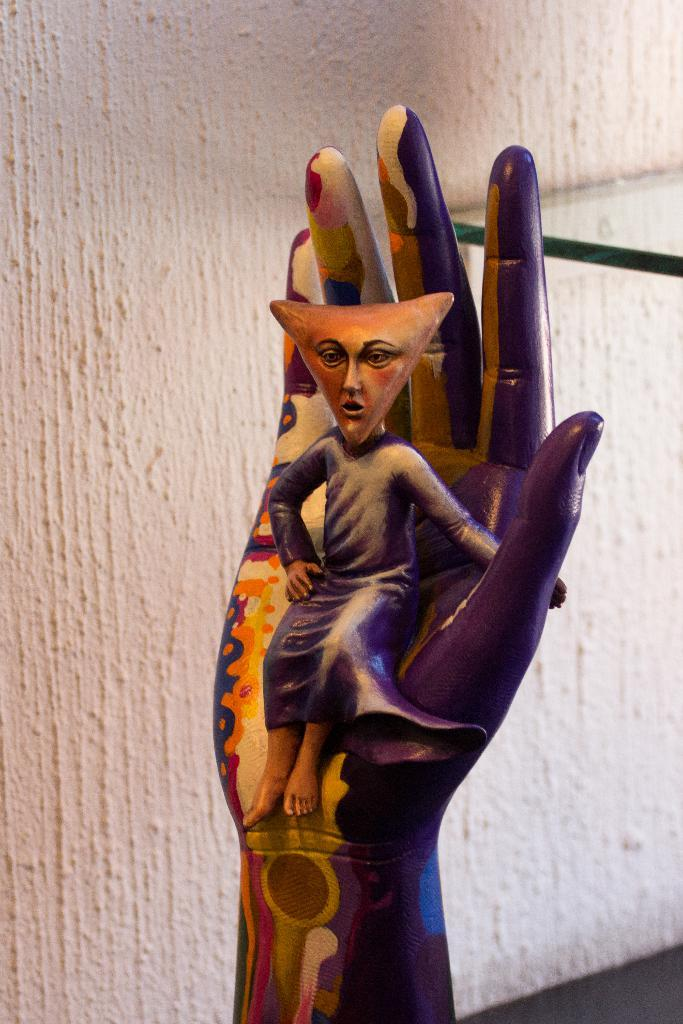What is the main subject of the image? The main subject of the image is a wood carving. Can you describe the wood carving in more detail? Unfortunately, the provided facts do not give any additional details about the wood carving. What time of day is depicted in the image? The provided facts do not mention the time of day, and there is no indication of time in the image. Is the wood carving being used for driving in the image? The wood carving is not a vehicle or related to driving; it is a stationary object in the image. 